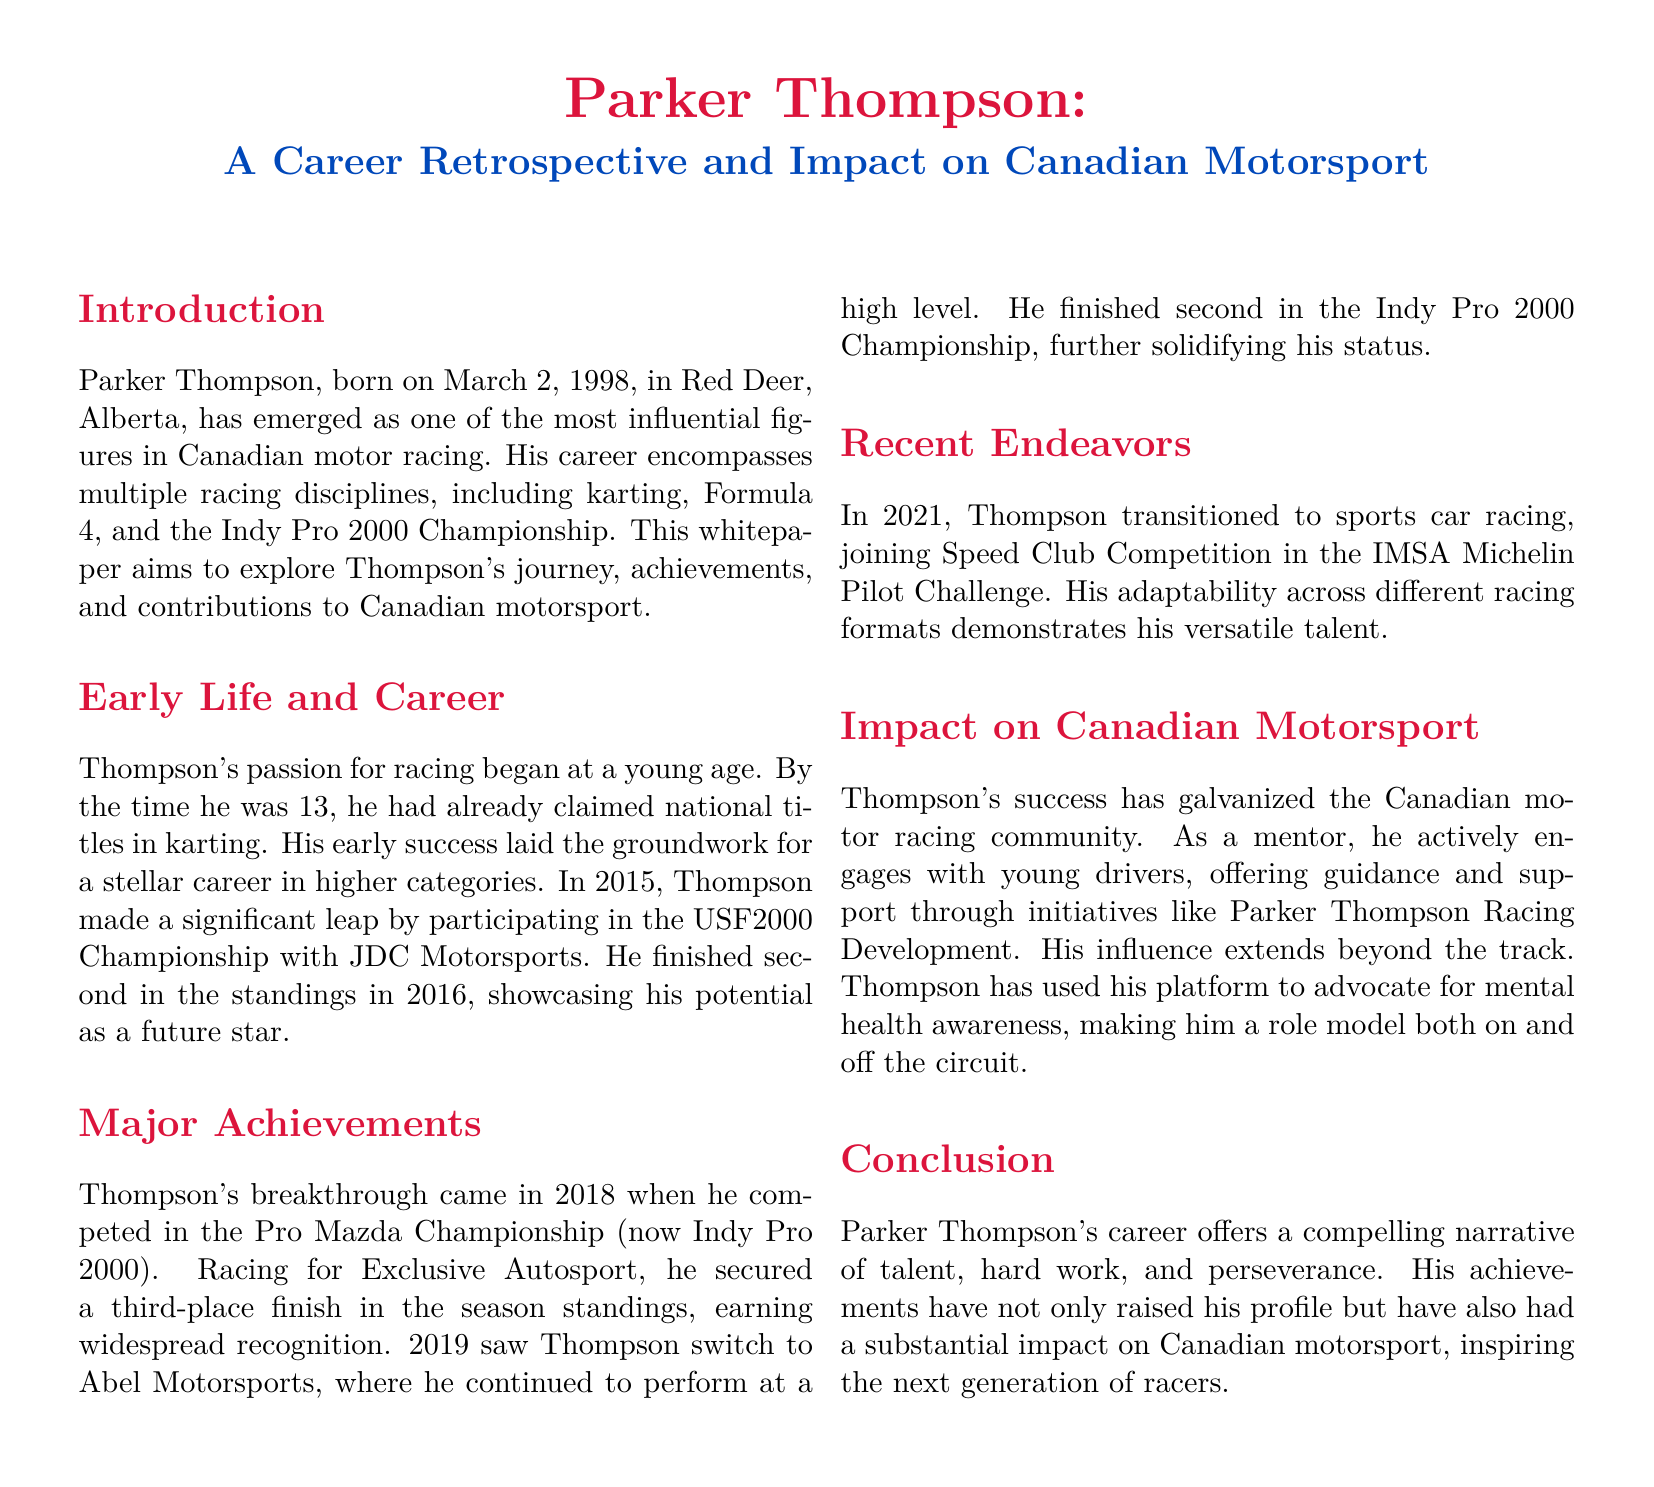what is Parker Thompson's birth date? The document states that Parker Thompson was born on March 2, 1998.
Answer: March 2, 1998 in which championship did Parker Thompson finish second in 2016? The text mentions that he finished second in the USF2000 Championship in 2016.
Answer: USF2000 Championship which team did Parker Thompson race for in the Pro Mazda Championship in 2018? According to the document, he raced for Exclusive Autosport in the Pro Mazda Championship.
Answer: Exclusive Autosport what major transition did Parker Thompson make in 2021? The document states that Thompson transitioned to sports car racing in 2021.
Answer: sports car racing what role does Parker Thompson have in the Canadian motor racing community? The document describes him as a mentor who offers guidance and support to young drivers.
Answer: mentor how has Parker Thompson contributed to mental health awareness? The document mentions that he has used his platform to advocate for mental health awareness.
Answer: advocate which racing category did Parker Thompson begin his career in? The document notes that he started his racing career in karting.
Answer: karting what is the name of the initiative Parker Thompson uses to support young drivers? The document states that he engages with young drivers through Parker Thompson Racing Development.
Answer: Parker Thompson Racing Development how many championships did Parker Thompson participate in before transitioning to sports cars? The document outlines that he participated in multiple championships, including karting, Formula 4, and Indy Pro 2000.
Answer: multiple championships 